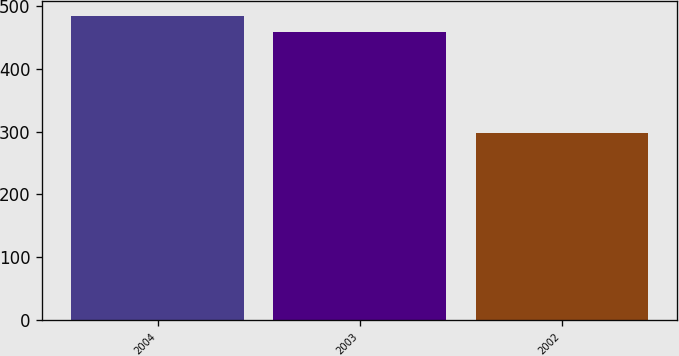Convert chart. <chart><loc_0><loc_0><loc_500><loc_500><bar_chart><fcel>2004<fcel>2003<fcel>2002<nl><fcel>484.4<fcel>458.6<fcel>298.6<nl></chart> 